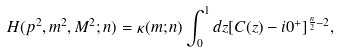<formula> <loc_0><loc_0><loc_500><loc_500>H ( p ^ { 2 } , m ^ { 2 } , M ^ { 2 } ; n ) = \kappa ( m ; n ) \int _ { 0 } ^ { 1 } d z [ C ( z ) - i 0 ^ { + } ] ^ { \frac { n } { 2 } - 2 } ,</formula> 